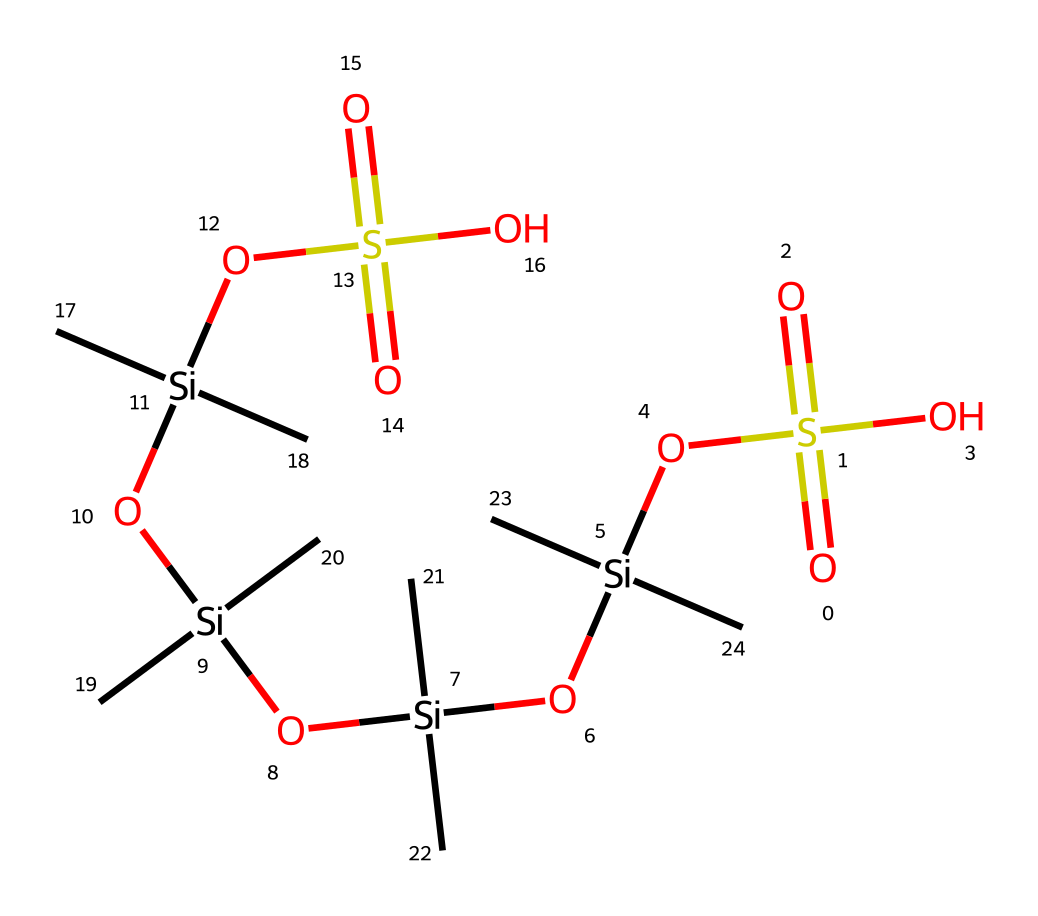What is the main functional group present in this chemical? The chemical structure contains multiple -OS(=O)(=O)O groups, indicating the presence of sulfonic acid functional groups.
Answer: sulfonic acid How many silicon atoms are in the chemical structure? By analyzing the SMILES representation, we can identify four silicon atoms present in the structure.
Answer: four What type of viscous property does this chemical exhibit? This chemical, based on its structure and composition of silicate and sulfonic acid groups, is characteristic of shear-thickening behavior typical in Non-Newtonian fluids.
Answer: shear-thickening How many carbon atoms are in the chemical structure? Counting the carbon atoms in the representation, we find there are twelve carbon atoms present.
Answer: twelve What contributes to the chemical's viscoelastic properties? The presence of silicate chains and the arrangement of sulfonic groups allow the material to exhibit viscoelastic behavior under stress conditions.
Answer: silicate chains What is the role of the sulfonic acid groups in this chemical? The sulfonic acid groups contribute to the fluid's properties by enhancing its ability to thicken under shear stress, crucial for protective applications.
Answer: thickening agent 